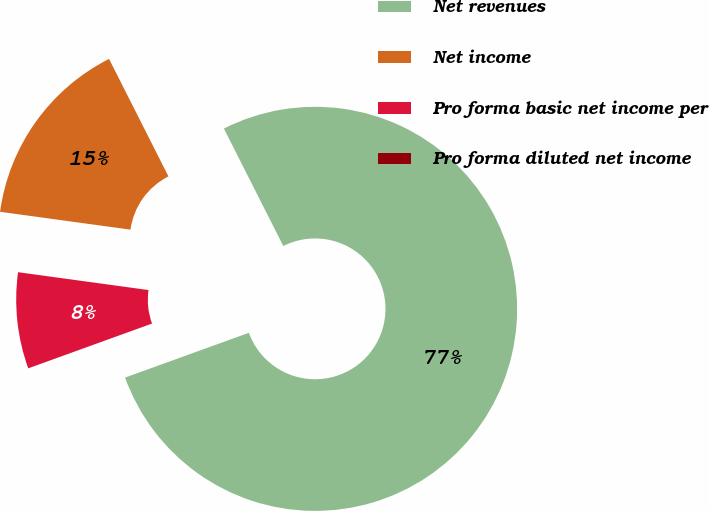Convert chart to OTSL. <chart><loc_0><loc_0><loc_500><loc_500><pie_chart><fcel>Net revenues<fcel>Net income<fcel>Pro forma basic net income per<fcel>Pro forma diluted net income<nl><fcel>76.92%<fcel>15.38%<fcel>7.69%<fcel>0.0%<nl></chart> 